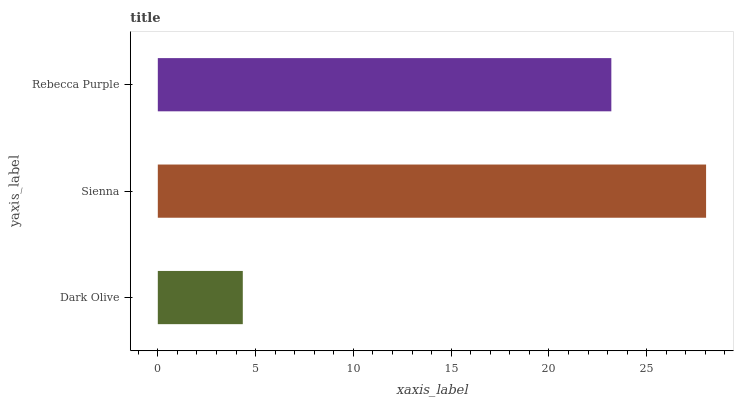Is Dark Olive the minimum?
Answer yes or no. Yes. Is Sienna the maximum?
Answer yes or no. Yes. Is Rebecca Purple the minimum?
Answer yes or no. No. Is Rebecca Purple the maximum?
Answer yes or no. No. Is Sienna greater than Rebecca Purple?
Answer yes or no. Yes. Is Rebecca Purple less than Sienna?
Answer yes or no. Yes. Is Rebecca Purple greater than Sienna?
Answer yes or no. No. Is Sienna less than Rebecca Purple?
Answer yes or no. No. Is Rebecca Purple the high median?
Answer yes or no. Yes. Is Rebecca Purple the low median?
Answer yes or no. Yes. Is Sienna the high median?
Answer yes or no. No. Is Sienna the low median?
Answer yes or no. No. 